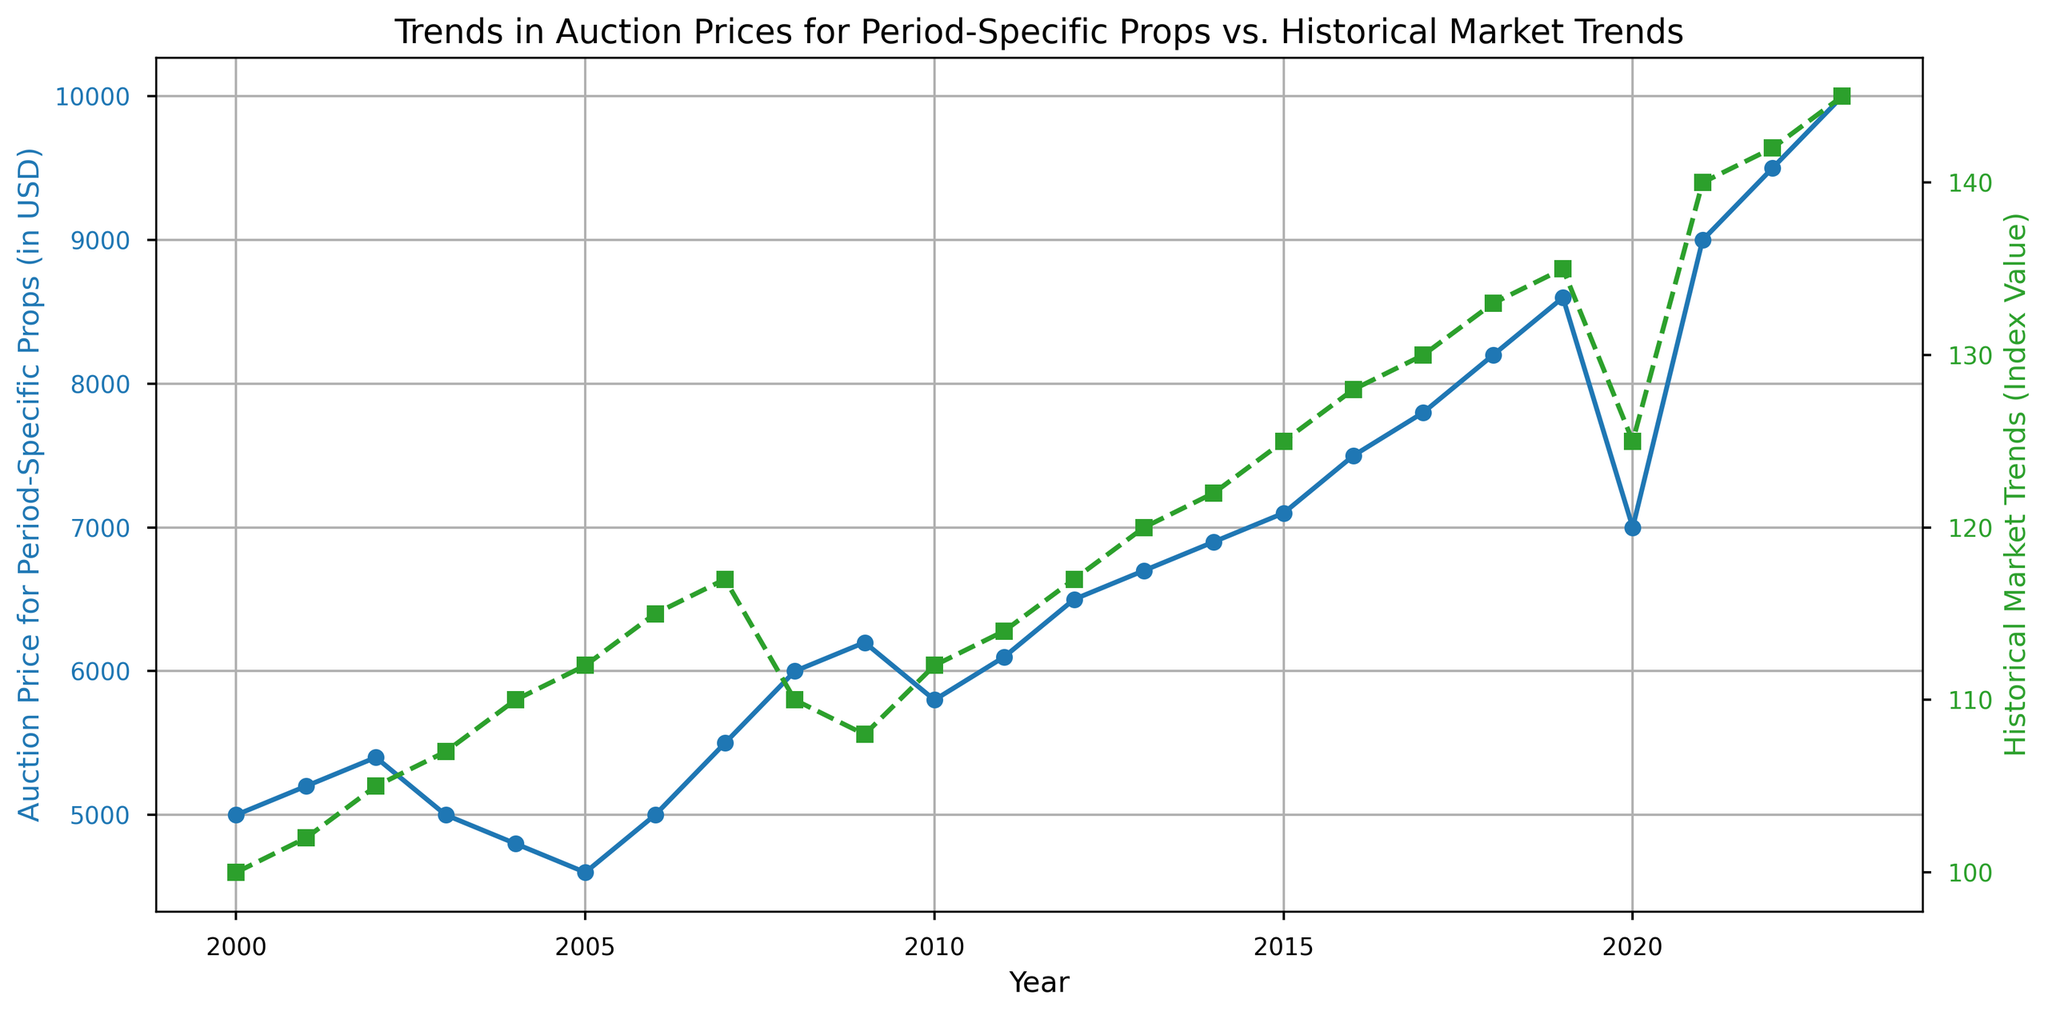What trend do auction prices for period-specific props generally show over the years? The blue line shows the auction prices from 2000 to 2023. Initially, prices fluctuate but start to climb steadily from around 2010, reaching a peak in 2023.
Answer: Steady increase How does the trend of historical market trends compare with auction prices after 2010? After 2010, both auction prices (blue line) and market trends (green line) show an upward trend. However, auction prices are more volatile, while market trends increase more steadily.
Answer: Similar upward trend What color represents the auction prices for period-specific props and the historical market trends? The blue line represents auction prices for period-specific props, and the green line represents historical market trends.
Answer: Blue and green In which year did the auction prices for period-specific props and historical market trends both show a significant upward spike? The blue line and green line both show a significant upward spike in 2021.
Answer: 2021 What was the auction price for period-specific props in 2010, and how did it change by 2022? In 2010, the auction price is approximately $5800 (blue line). By 2022, it increases to about $9500.
Answer: $5800 to $9500 By how much did auction prices for period-specific props change between 2008 and 2009? The auction prices in 2008 were $6000 and in 2009 were $6200. The change is $6200 - $6000 = $200.
Answer: $200 Are there any years where auction prices for period-specific props decrease while historical market trends increase? In 2004 and 2005, the blue line (auction prices) decreases while the green line (historical market trends) increases.
Answer: 2004, 2005 Which had a higher relative increase from 2008 to 2009, auction prices or historical market trends? From 2008 to 2009, auction prices increased from $6000 to $6200, a 3.33% increase. Historical market trends decreased from 110 to 108, a -1.82% change. Relative increase is higher for auction prices.
Answer: Auction prices During which period did the auction prices for period-specific props experience a significant drop? Between 2002 and 2006, the blue line shows a drop from about $5400 to $4600.
Answer: 2002-2006 If you average the auction prices for period-specific props between 2020 and 2023, what value do you get? The prices are $7000 (2020), $9000 (2021), $9500 (2022), and $10000 (2023). The average is (7000 + 9000 + 9500 + 10000)/4 = 8875.
Answer: 8875 